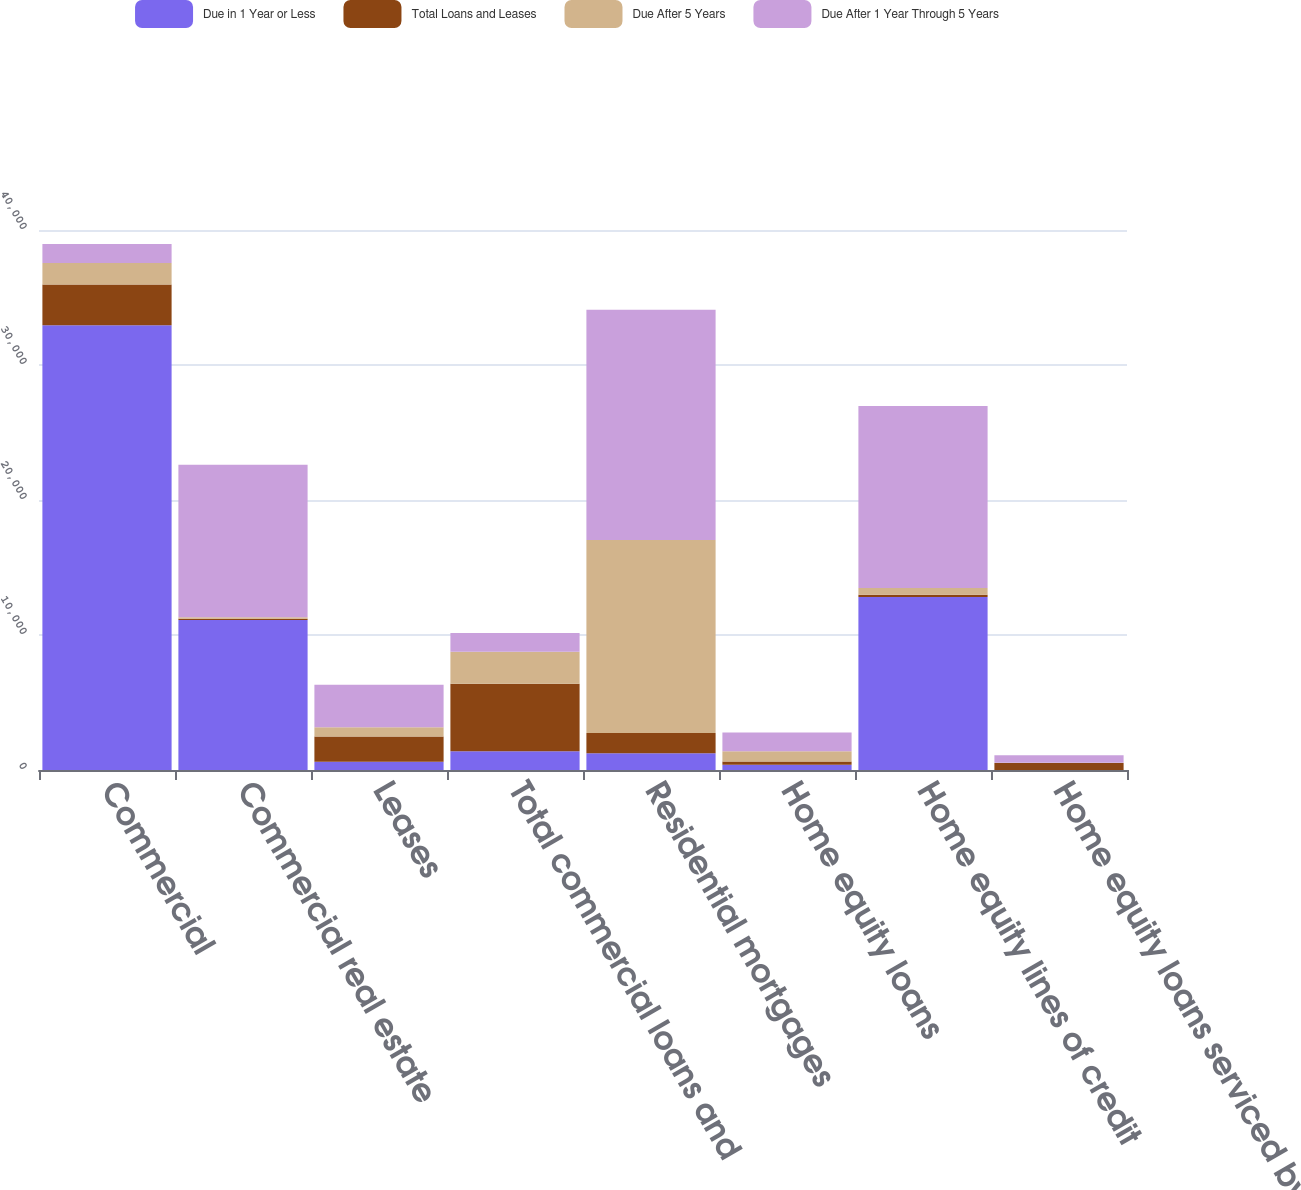Convert chart to OTSL. <chart><loc_0><loc_0><loc_500><loc_500><stacked_bar_chart><ecel><fcel>Commercial<fcel>Commercial real estate<fcel>Leases<fcel>Total commercial loans and<fcel>Residential mortgages<fcel>Home equity loans<fcel>Home equity lines of credit<fcel>Home equity loans serviced by<nl><fcel>Due in 1 Year or Less<fcel>32953<fcel>11104<fcel>605<fcel>1392<fcel>1248<fcel>385<fcel>12822<fcel>1<nl><fcel>Total Loans and Leases<fcel>3012<fcel>104<fcel>1879<fcel>4995<fcel>1501<fcel>236<fcel>155<fcel>509<nl><fcel>Due After 5 Years<fcel>1597<fcel>100<fcel>677<fcel>2374<fcel>14296<fcel>771<fcel>506<fcel>32<nl><fcel>Due After 1 Year Through 5 Years<fcel>1392<fcel>11308<fcel>3161<fcel>1392<fcel>17045<fcel>1392<fcel>13483<fcel>542<nl></chart> 